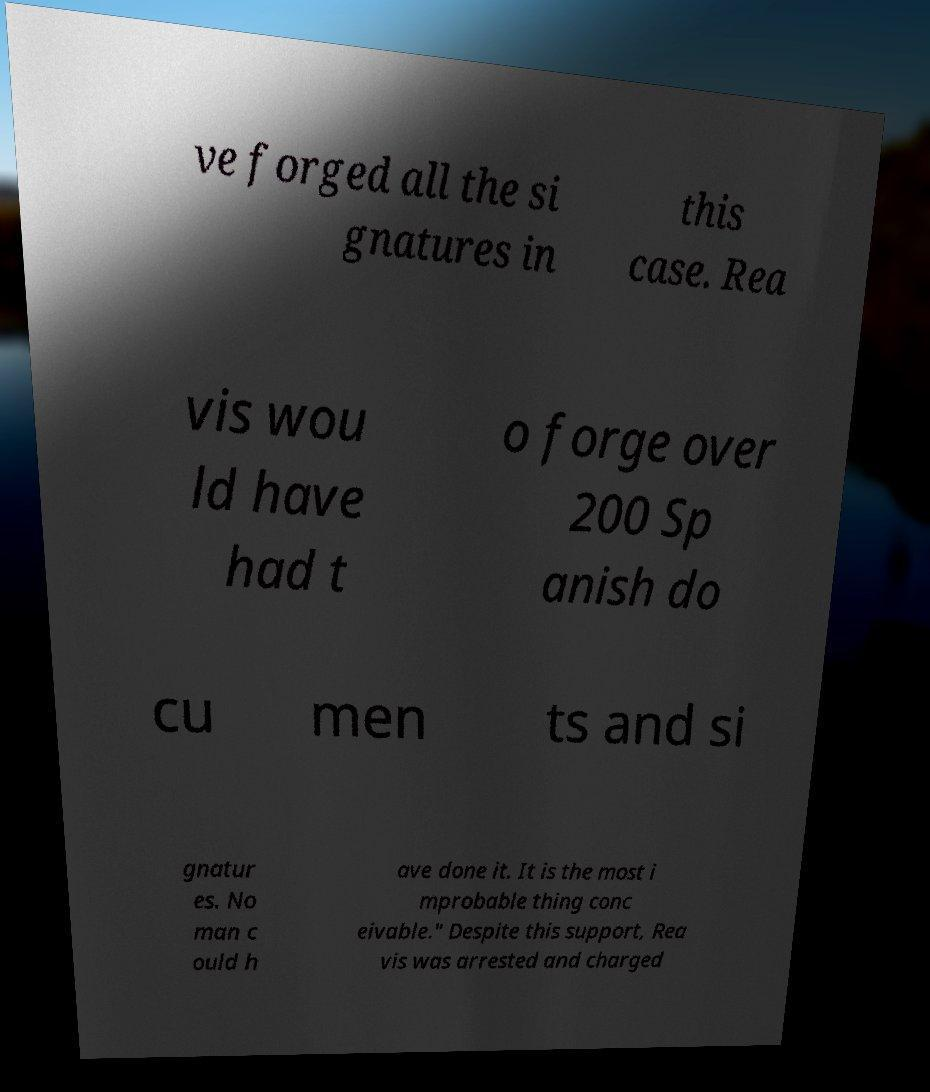Could you extract and type out the text from this image? ve forged all the si gnatures in this case. Rea vis wou ld have had t o forge over 200 Sp anish do cu men ts and si gnatur es. No man c ould h ave done it. It is the most i mprobable thing conc eivable." Despite this support, Rea vis was arrested and charged 